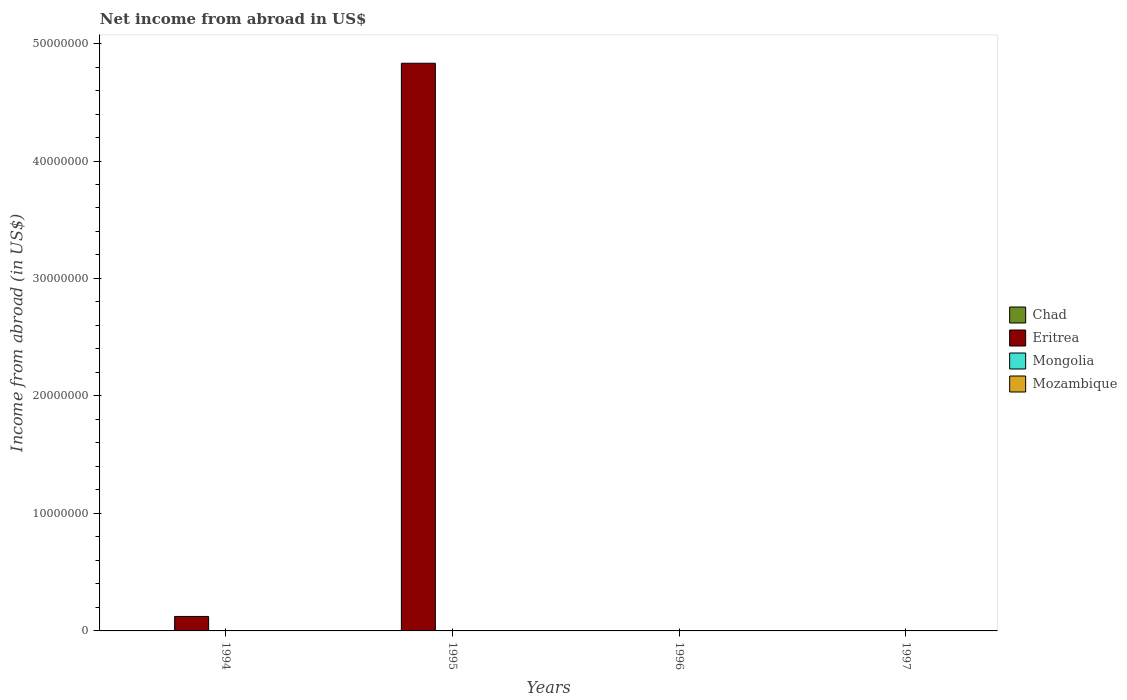How many bars are there on the 2nd tick from the left?
Give a very brief answer. 1. What is the label of the 4th group of bars from the left?
Provide a short and direct response. 1997. In how many cases, is the number of bars for a given year not equal to the number of legend labels?
Make the answer very short. 4. Across all years, what is the maximum net income from abroad in Eritrea?
Give a very brief answer. 4.83e+07. What is the difference between the net income from abroad in Eritrea in 1994 and that in 1995?
Keep it short and to the point. -4.71e+07. What is the difference between the net income from abroad in Eritrea in 1994 and the net income from abroad in Chad in 1995?
Your answer should be very brief. 1.23e+06. In how many years, is the net income from abroad in Mozambique greater than 38000000 US$?
Your answer should be compact. 0. What is the difference between the highest and the lowest net income from abroad in Eritrea?
Ensure brevity in your answer.  4.83e+07. Is it the case that in every year, the sum of the net income from abroad in Chad and net income from abroad in Mozambique is greater than the net income from abroad in Eritrea?
Your answer should be compact. No. Are all the bars in the graph horizontal?
Ensure brevity in your answer.  No. How many legend labels are there?
Your answer should be very brief. 4. What is the title of the graph?
Make the answer very short. Net income from abroad in US$. Does "Swaziland" appear as one of the legend labels in the graph?
Give a very brief answer. No. What is the label or title of the X-axis?
Provide a short and direct response. Years. What is the label or title of the Y-axis?
Your answer should be very brief. Income from abroad (in US$). What is the Income from abroad (in US$) in Eritrea in 1994?
Your answer should be very brief. 1.23e+06. What is the Income from abroad (in US$) of Mongolia in 1994?
Offer a very short reply. 0. What is the Income from abroad (in US$) of Eritrea in 1995?
Your answer should be very brief. 4.83e+07. What is the Income from abroad (in US$) of Chad in 1996?
Make the answer very short. 0. What is the Income from abroad (in US$) in Eritrea in 1996?
Your answer should be very brief. 0. What is the Income from abroad (in US$) in Mongolia in 1996?
Ensure brevity in your answer.  0. What is the Income from abroad (in US$) in Mozambique in 1996?
Ensure brevity in your answer.  0. What is the Income from abroad (in US$) of Eritrea in 1997?
Your answer should be very brief. 0. What is the Income from abroad (in US$) of Mozambique in 1997?
Provide a short and direct response. 0. Across all years, what is the maximum Income from abroad (in US$) in Eritrea?
Ensure brevity in your answer.  4.83e+07. What is the total Income from abroad (in US$) of Chad in the graph?
Offer a terse response. 0. What is the total Income from abroad (in US$) in Eritrea in the graph?
Offer a terse response. 4.96e+07. What is the total Income from abroad (in US$) of Mongolia in the graph?
Give a very brief answer. 0. What is the total Income from abroad (in US$) in Mozambique in the graph?
Keep it short and to the point. 0. What is the difference between the Income from abroad (in US$) of Eritrea in 1994 and that in 1995?
Offer a very short reply. -4.71e+07. What is the average Income from abroad (in US$) in Eritrea per year?
Ensure brevity in your answer.  1.24e+07. What is the ratio of the Income from abroad (in US$) in Eritrea in 1994 to that in 1995?
Offer a terse response. 0.03. What is the difference between the highest and the lowest Income from abroad (in US$) in Eritrea?
Ensure brevity in your answer.  4.83e+07. 